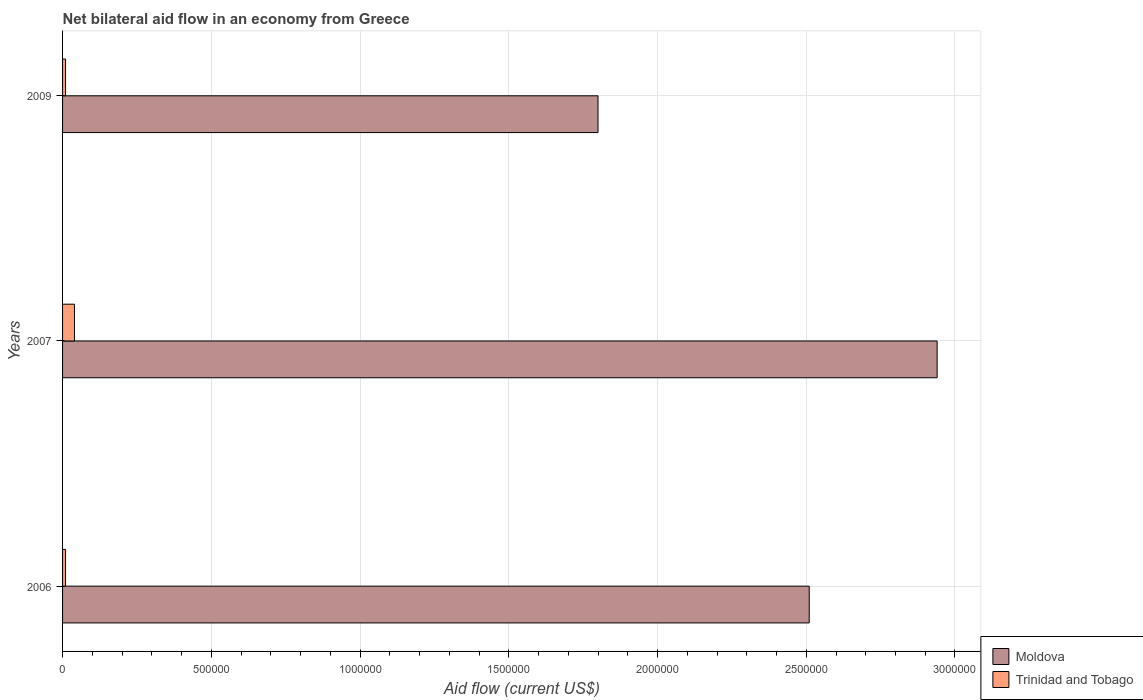How many different coloured bars are there?
Your answer should be very brief. 2. How many groups of bars are there?
Provide a succinct answer. 3. Are the number of bars on each tick of the Y-axis equal?
Your answer should be compact. Yes. How many bars are there on the 3rd tick from the top?
Provide a short and direct response. 2. How many bars are there on the 1st tick from the bottom?
Your response must be concise. 2. What is the label of the 1st group of bars from the top?
Provide a short and direct response. 2009. In how many cases, is the number of bars for a given year not equal to the number of legend labels?
Give a very brief answer. 0. What is the net bilateral aid flow in Moldova in 2009?
Offer a terse response. 1.80e+06. Across all years, what is the maximum net bilateral aid flow in Trinidad and Tobago?
Make the answer very short. 4.00e+04. In which year was the net bilateral aid flow in Moldova maximum?
Ensure brevity in your answer.  2007. What is the total net bilateral aid flow in Moldova in the graph?
Your answer should be very brief. 7.25e+06. What is the difference between the net bilateral aid flow in Trinidad and Tobago in 2007 and that in 2009?
Offer a very short reply. 3.00e+04. What is the difference between the net bilateral aid flow in Moldova in 2009 and the net bilateral aid flow in Trinidad and Tobago in 2007?
Your answer should be very brief. 1.76e+06. What is the average net bilateral aid flow in Trinidad and Tobago per year?
Provide a short and direct response. 2.00e+04. In the year 2009, what is the difference between the net bilateral aid flow in Moldova and net bilateral aid flow in Trinidad and Tobago?
Your answer should be very brief. 1.79e+06. In how many years, is the net bilateral aid flow in Moldova greater than 2400000 US$?
Offer a very short reply. 2. What is the ratio of the net bilateral aid flow in Trinidad and Tobago in 2007 to that in 2009?
Ensure brevity in your answer.  4. Is the difference between the net bilateral aid flow in Moldova in 2006 and 2009 greater than the difference between the net bilateral aid flow in Trinidad and Tobago in 2006 and 2009?
Provide a short and direct response. Yes. What is the difference between the highest and the second highest net bilateral aid flow in Trinidad and Tobago?
Offer a terse response. 3.00e+04. What is the difference between the highest and the lowest net bilateral aid flow in Moldova?
Your response must be concise. 1.14e+06. In how many years, is the net bilateral aid flow in Trinidad and Tobago greater than the average net bilateral aid flow in Trinidad and Tobago taken over all years?
Your answer should be compact. 1. Is the sum of the net bilateral aid flow in Moldova in 2006 and 2007 greater than the maximum net bilateral aid flow in Trinidad and Tobago across all years?
Provide a short and direct response. Yes. What does the 2nd bar from the top in 2007 represents?
Your response must be concise. Moldova. What does the 2nd bar from the bottom in 2006 represents?
Ensure brevity in your answer.  Trinidad and Tobago. Are all the bars in the graph horizontal?
Offer a very short reply. Yes. What is the difference between two consecutive major ticks on the X-axis?
Your answer should be very brief. 5.00e+05. Are the values on the major ticks of X-axis written in scientific E-notation?
Provide a short and direct response. No. Where does the legend appear in the graph?
Ensure brevity in your answer.  Bottom right. How many legend labels are there?
Keep it short and to the point. 2. What is the title of the graph?
Offer a very short reply. Net bilateral aid flow in an economy from Greece. Does "Fragile and conflict affected situations" appear as one of the legend labels in the graph?
Provide a succinct answer. No. What is the label or title of the X-axis?
Make the answer very short. Aid flow (current US$). What is the label or title of the Y-axis?
Make the answer very short. Years. What is the Aid flow (current US$) of Moldova in 2006?
Offer a very short reply. 2.51e+06. What is the Aid flow (current US$) of Trinidad and Tobago in 2006?
Keep it short and to the point. 10000. What is the Aid flow (current US$) of Moldova in 2007?
Provide a short and direct response. 2.94e+06. What is the Aid flow (current US$) in Trinidad and Tobago in 2007?
Give a very brief answer. 4.00e+04. What is the Aid flow (current US$) of Moldova in 2009?
Ensure brevity in your answer.  1.80e+06. Across all years, what is the maximum Aid flow (current US$) in Moldova?
Keep it short and to the point. 2.94e+06. Across all years, what is the minimum Aid flow (current US$) of Moldova?
Offer a terse response. 1.80e+06. Across all years, what is the minimum Aid flow (current US$) in Trinidad and Tobago?
Provide a short and direct response. 10000. What is the total Aid flow (current US$) of Moldova in the graph?
Make the answer very short. 7.25e+06. What is the total Aid flow (current US$) of Trinidad and Tobago in the graph?
Provide a succinct answer. 6.00e+04. What is the difference between the Aid flow (current US$) in Moldova in 2006 and that in 2007?
Your answer should be very brief. -4.30e+05. What is the difference between the Aid flow (current US$) of Moldova in 2006 and that in 2009?
Provide a succinct answer. 7.10e+05. What is the difference between the Aid flow (current US$) of Moldova in 2007 and that in 2009?
Provide a short and direct response. 1.14e+06. What is the difference between the Aid flow (current US$) in Moldova in 2006 and the Aid flow (current US$) in Trinidad and Tobago in 2007?
Provide a short and direct response. 2.47e+06. What is the difference between the Aid flow (current US$) of Moldova in 2006 and the Aid flow (current US$) of Trinidad and Tobago in 2009?
Provide a short and direct response. 2.50e+06. What is the difference between the Aid flow (current US$) in Moldova in 2007 and the Aid flow (current US$) in Trinidad and Tobago in 2009?
Your answer should be very brief. 2.93e+06. What is the average Aid flow (current US$) of Moldova per year?
Offer a very short reply. 2.42e+06. In the year 2006, what is the difference between the Aid flow (current US$) in Moldova and Aid flow (current US$) in Trinidad and Tobago?
Give a very brief answer. 2.50e+06. In the year 2007, what is the difference between the Aid flow (current US$) of Moldova and Aid flow (current US$) of Trinidad and Tobago?
Offer a very short reply. 2.90e+06. In the year 2009, what is the difference between the Aid flow (current US$) in Moldova and Aid flow (current US$) in Trinidad and Tobago?
Offer a very short reply. 1.79e+06. What is the ratio of the Aid flow (current US$) of Moldova in 2006 to that in 2007?
Your answer should be very brief. 0.85. What is the ratio of the Aid flow (current US$) in Trinidad and Tobago in 2006 to that in 2007?
Make the answer very short. 0.25. What is the ratio of the Aid flow (current US$) of Moldova in 2006 to that in 2009?
Keep it short and to the point. 1.39. What is the ratio of the Aid flow (current US$) of Trinidad and Tobago in 2006 to that in 2009?
Make the answer very short. 1. What is the ratio of the Aid flow (current US$) in Moldova in 2007 to that in 2009?
Offer a terse response. 1.63. What is the ratio of the Aid flow (current US$) in Trinidad and Tobago in 2007 to that in 2009?
Your answer should be compact. 4. What is the difference between the highest and the lowest Aid flow (current US$) in Moldova?
Ensure brevity in your answer.  1.14e+06. What is the difference between the highest and the lowest Aid flow (current US$) in Trinidad and Tobago?
Your response must be concise. 3.00e+04. 